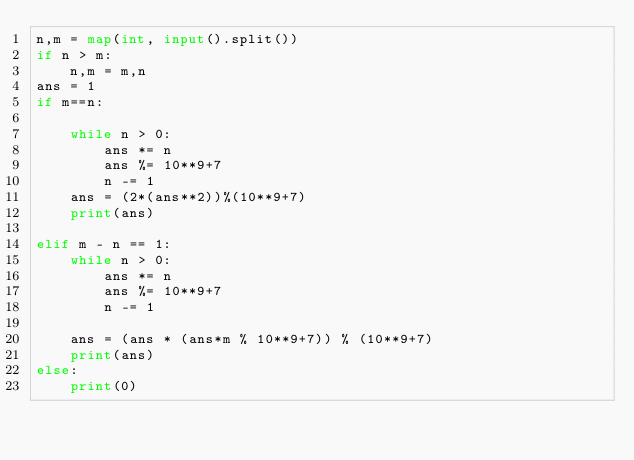Convert code to text. <code><loc_0><loc_0><loc_500><loc_500><_Python_>n,m = map(int, input().split())
if n > m:
    n,m = m,n
ans = 1
if m==n:

    while n > 0:
        ans *= n
        ans %= 10**9+7
        n -= 1
    ans = (2*(ans**2))%(10**9+7)
    print(ans)

elif m - n == 1:
    while n > 0:
        ans *= n
        ans %= 10**9+7
        n -= 1
    
    ans = (ans * (ans*m % 10**9+7)) % (10**9+7)
    print(ans)
else:
    print(0)
</code> 